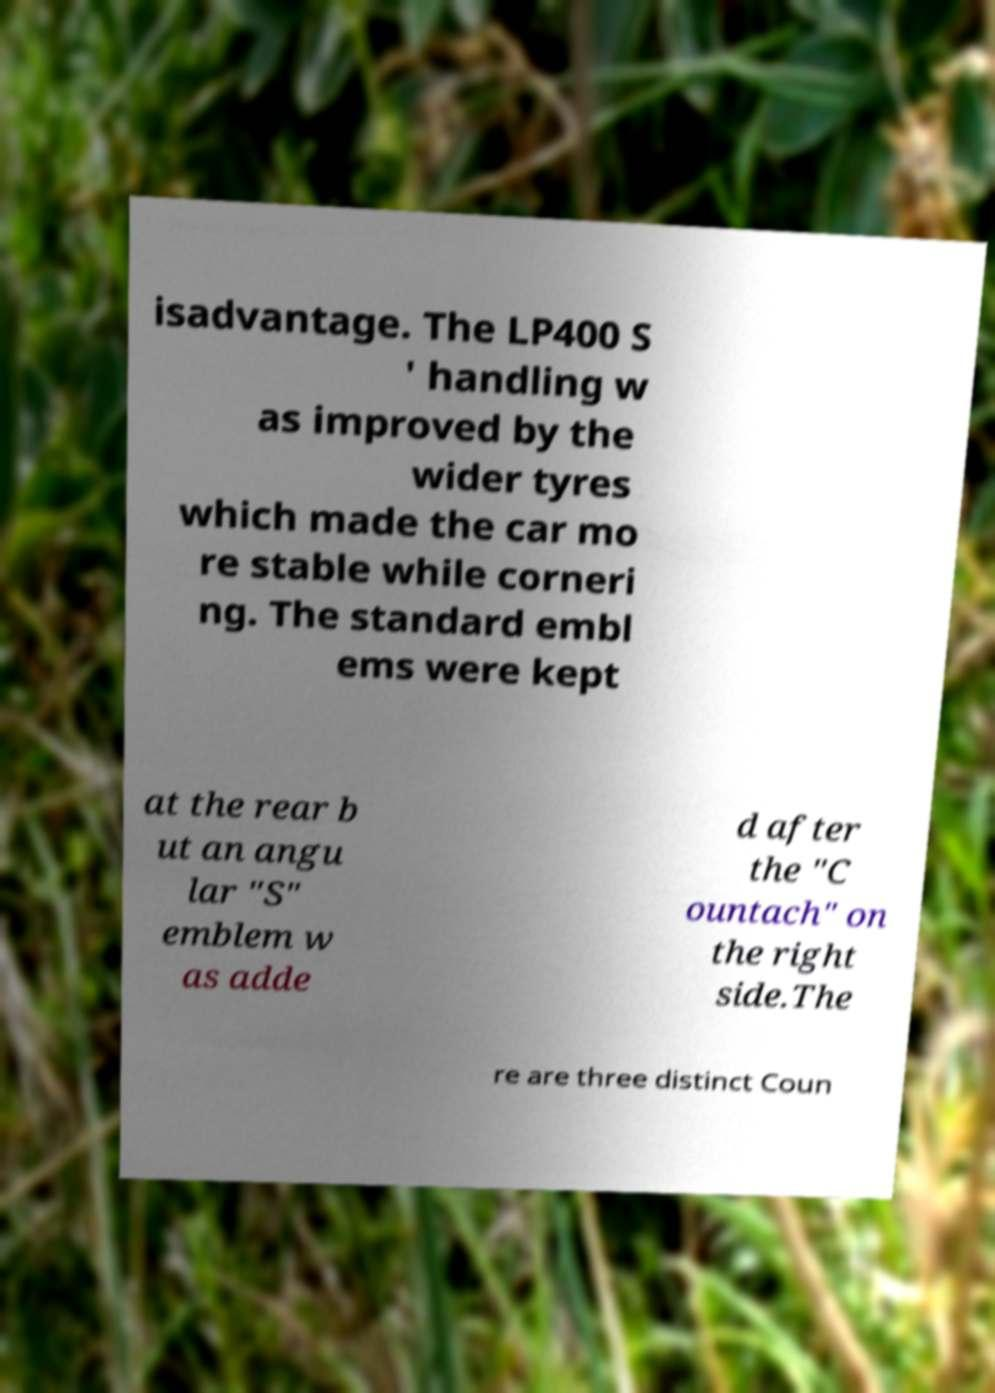Please read and relay the text visible in this image. What does it say? isadvantage. The LP400 S ' handling w as improved by the wider tyres which made the car mo re stable while corneri ng. The standard embl ems were kept at the rear b ut an angu lar "S" emblem w as adde d after the "C ountach" on the right side.The re are three distinct Coun 